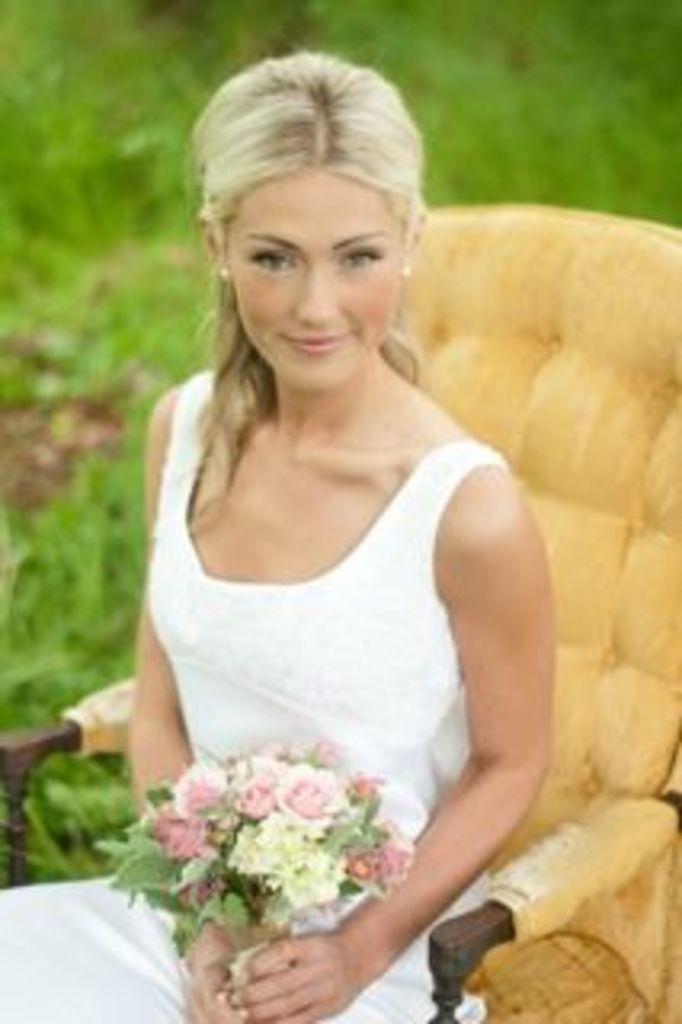Can you describe this image briefly? In this image there is a girl sitting on the chair. She is holding a bouquet. Behind her there's grass on the ground. 